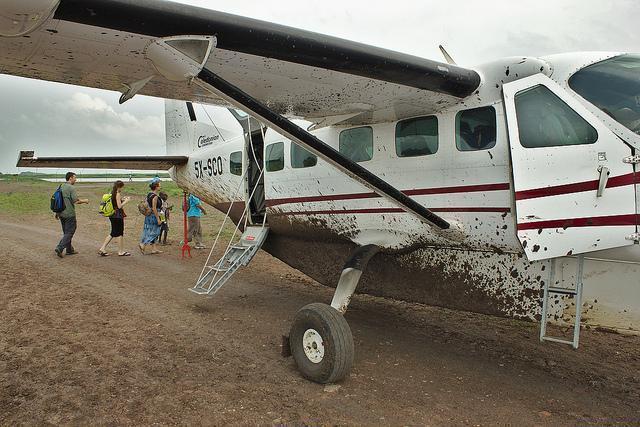What had recently happened when this plane landed prior to this place?
Choose the correct response and explain in the format: 'Answer: answer
Rationale: rationale.'
Options: Snow, rain, sunny day, tornado. Answer: rain.
Rationale: There is lots of mud, so there had been also rain. 